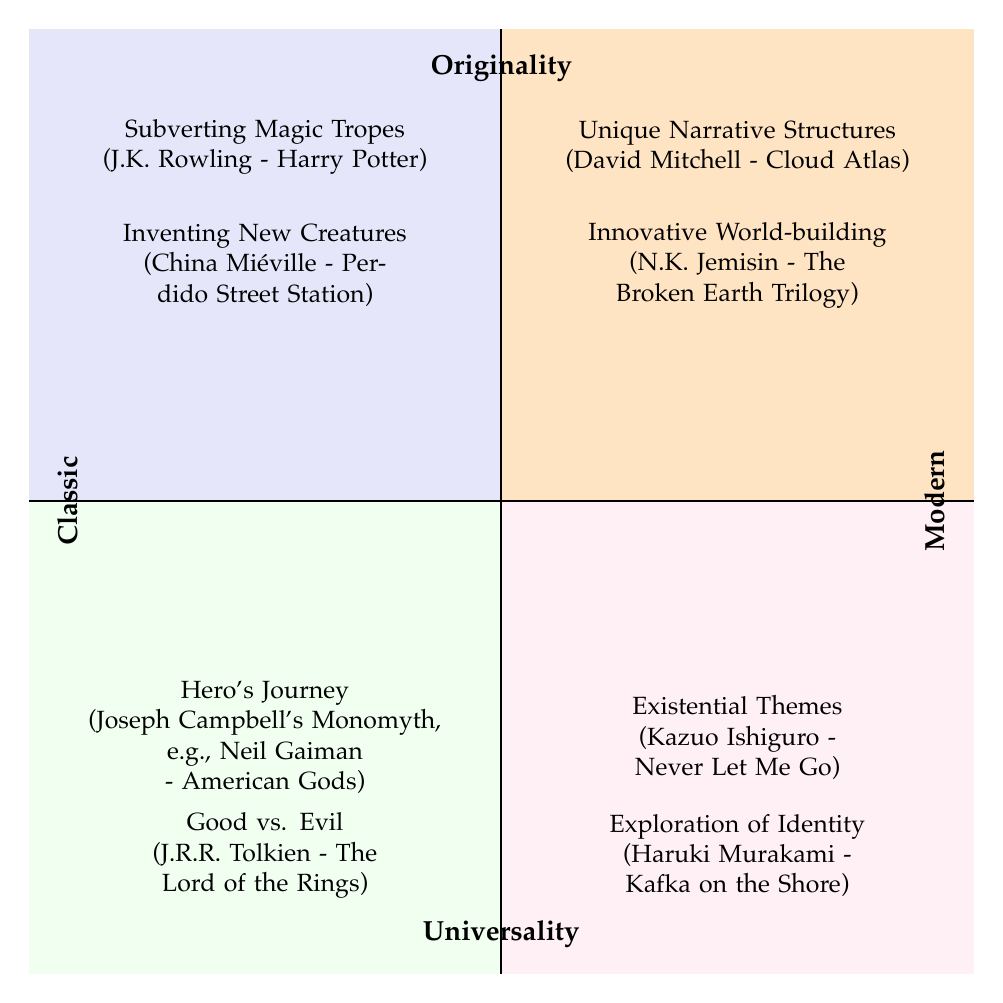What are the two themes represented in the quadrants? The diagram divides the themes into two categories: Originality and Universality. Each quadrant represents a combination of these two themes, leading to different story aspects.
Answer: Originality, Universality How many nodes are in the Classic quadrant? The Classic quadrant has two nodes: Good vs. Evil and Hero's Journey, which are the main themes mentioned in classic literature.
Answer: 2 Which author's work is associated with the theme of Existential Themes? By examining the Modern/Universality quadrant, the only author associated with Existential Themes is Kazuo Ishiguro.
Answer: Kazuo Ishiguro What type of narrative is represented in the Originality quadrant by David Mitchell? In the quadrant, David Mitchell's work Cloud Atlas is noted for having Unique Narrative Structures under the Originality theme.
Answer: Unique Narrative Structures Which work is categorized under Subverting Magic Tropes? Subverting Magic Tropes is attributed to J.K. Rowling's work Harry Potter, found in the Classic/Originality quadrant.
Answer: Harry Potter How many nodes are in the Modern/Originality quadrant? The Modern/Originality quadrant contains two nodes: Unique Narrative Structures and Innovative World-building, each representing modern storytelling techniques.
Answer: 2 What commonality is found between Hero's Journey and Good vs. Evil? Both of these themes fall under the Classic/Universality quadrant, representing fundamental and universally recognized storylines.
Answer: Classic/Universality Which author invented new creatures in the realm of Originality? The diagram states that China Miéville's work Perdido Street Station involves Inventing New Creatures, which is in the Classic/Originality quadrant.
Answer: China Miéville 